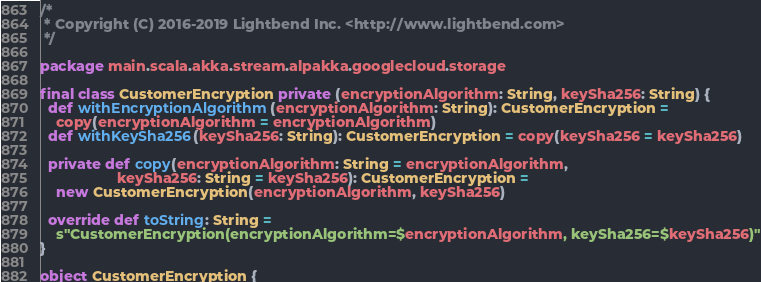<code> <loc_0><loc_0><loc_500><loc_500><_Scala_>/*
 * Copyright (C) 2016-2019 Lightbend Inc. <http://www.lightbend.com>
 */

package main.scala.akka.stream.alpakka.googlecloud.storage

final class CustomerEncryption private (encryptionAlgorithm: String, keySha256: String) {
  def withEncryptionAlgorithm(encryptionAlgorithm: String): CustomerEncryption =
    copy(encryptionAlgorithm = encryptionAlgorithm)
  def withKeySha256(keySha256: String): CustomerEncryption = copy(keySha256 = keySha256)

  private def copy(encryptionAlgorithm: String = encryptionAlgorithm,
                   keySha256: String = keySha256): CustomerEncryption =
    new CustomerEncryption(encryptionAlgorithm, keySha256)

  override def toString: String =
    s"CustomerEncryption(encryptionAlgorithm=$encryptionAlgorithm, keySha256=$keySha256)"
}

object CustomerEncryption {</code> 